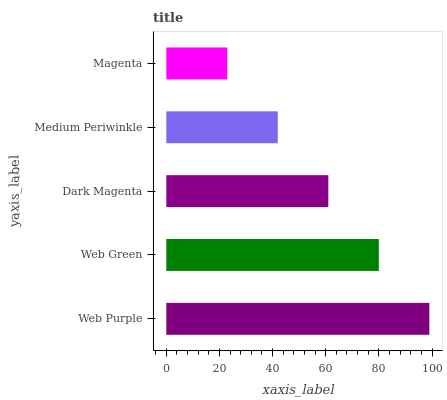Is Magenta the minimum?
Answer yes or no. Yes. Is Web Purple the maximum?
Answer yes or no. Yes. Is Web Green the minimum?
Answer yes or no. No. Is Web Green the maximum?
Answer yes or no. No. Is Web Purple greater than Web Green?
Answer yes or no. Yes. Is Web Green less than Web Purple?
Answer yes or no. Yes. Is Web Green greater than Web Purple?
Answer yes or no. No. Is Web Purple less than Web Green?
Answer yes or no. No. Is Dark Magenta the high median?
Answer yes or no. Yes. Is Dark Magenta the low median?
Answer yes or no. Yes. Is Magenta the high median?
Answer yes or no. No. Is Medium Periwinkle the low median?
Answer yes or no. No. 